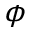<formula> <loc_0><loc_0><loc_500><loc_500>\phi</formula> 